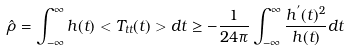<formula> <loc_0><loc_0><loc_500><loc_500>\hat { \rho } = \int _ { - \infty } ^ { \infty } h ( t ) < T _ { t t } ( t ) > d t \geq - \frac { 1 } { 2 4 \pi } \int _ { - \infty } ^ { \infty } \frac { h ^ { ^ { \prime } } ( t ) ^ { 2 } } { h ( t ) } d t</formula> 